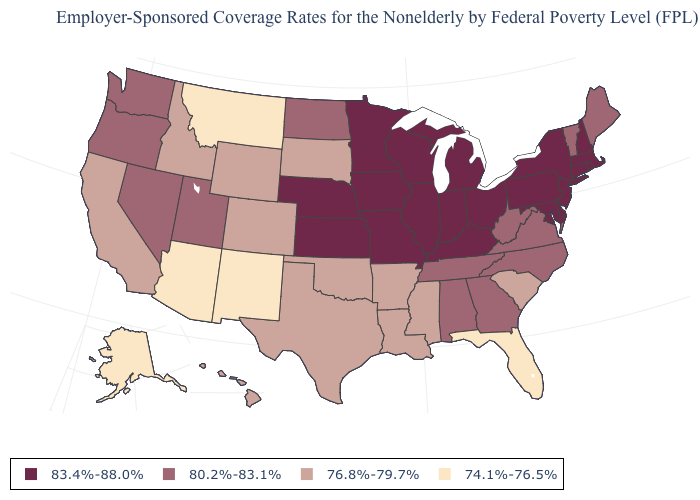Does the first symbol in the legend represent the smallest category?
Short answer required. No. Which states hav the highest value in the West?
Short answer required. Nevada, Oregon, Utah, Washington. Among the states that border Montana , which have the lowest value?
Concise answer only. Idaho, South Dakota, Wyoming. What is the value of Connecticut?
Short answer required. 83.4%-88.0%. What is the lowest value in states that border Arkansas?
Write a very short answer. 76.8%-79.7%. Which states have the lowest value in the USA?
Quick response, please. Alaska, Arizona, Florida, Montana, New Mexico. Name the states that have a value in the range 80.2%-83.1%?
Write a very short answer. Alabama, Georgia, Maine, Nevada, North Carolina, North Dakota, Oregon, Tennessee, Utah, Vermont, Virginia, Washington, West Virginia. Among the states that border New York , does Connecticut have the lowest value?
Concise answer only. No. What is the value of New Mexico?
Concise answer only. 74.1%-76.5%. What is the lowest value in states that border Kentucky?
Keep it brief. 80.2%-83.1%. What is the lowest value in the West?
Short answer required. 74.1%-76.5%. Does Maryland have the highest value in the USA?
Short answer required. Yes. What is the highest value in states that border Alabama?
Give a very brief answer. 80.2%-83.1%. Does the map have missing data?
Give a very brief answer. No. What is the highest value in the USA?
Write a very short answer. 83.4%-88.0%. 